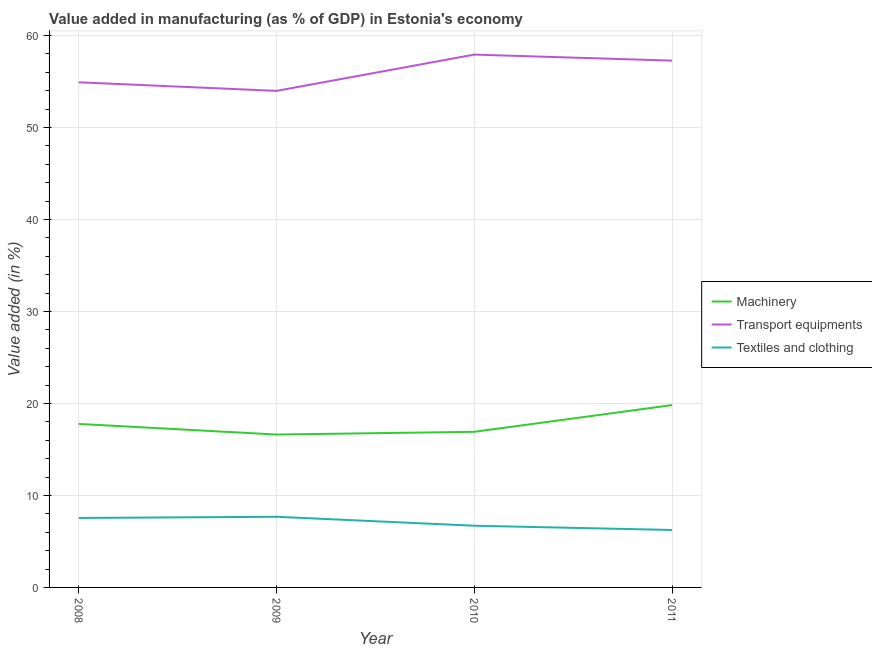How many different coloured lines are there?
Offer a terse response. 3. Is the number of lines equal to the number of legend labels?
Provide a succinct answer. Yes. What is the value added in manufacturing textile and clothing in 2009?
Keep it short and to the point. 7.68. Across all years, what is the maximum value added in manufacturing textile and clothing?
Ensure brevity in your answer.  7.68. Across all years, what is the minimum value added in manufacturing machinery?
Your answer should be compact. 16.62. In which year was the value added in manufacturing machinery minimum?
Offer a very short reply. 2009. What is the total value added in manufacturing machinery in the graph?
Your response must be concise. 71.12. What is the difference between the value added in manufacturing machinery in 2008 and that in 2011?
Provide a succinct answer. -2.05. What is the difference between the value added in manufacturing machinery in 2011 and the value added in manufacturing textile and clothing in 2009?
Your answer should be compact. 12.14. What is the average value added in manufacturing machinery per year?
Offer a terse response. 17.78. In the year 2011, what is the difference between the value added in manufacturing transport equipments and value added in manufacturing textile and clothing?
Keep it short and to the point. 51.01. What is the ratio of the value added in manufacturing textile and clothing in 2009 to that in 2010?
Provide a succinct answer. 1.15. Is the value added in manufacturing textile and clothing in 2008 less than that in 2011?
Give a very brief answer. No. What is the difference between the highest and the second highest value added in manufacturing textile and clothing?
Your answer should be very brief. 0.13. What is the difference between the highest and the lowest value added in manufacturing transport equipments?
Offer a terse response. 3.94. In how many years, is the value added in manufacturing machinery greater than the average value added in manufacturing machinery taken over all years?
Give a very brief answer. 1. Is it the case that in every year, the sum of the value added in manufacturing machinery and value added in manufacturing transport equipments is greater than the value added in manufacturing textile and clothing?
Offer a terse response. Yes. Does the value added in manufacturing textile and clothing monotonically increase over the years?
Your response must be concise. No. Is the value added in manufacturing machinery strictly greater than the value added in manufacturing transport equipments over the years?
Offer a very short reply. No. How many lines are there?
Your response must be concise. 3. Are the values on the major ticks of Y-axis written in scientific E-notation?
Offer a very short reply. No. Does the graph contain any zero values?
Your answer should be very brief. No. Does the graph contain grids?
Provide a succinct answer. Yes. What is the title of the graph?
Your response must be concise. Value added in manufacturing (as % of GDP) in Estonia's economy. Does "Renewable sources" appear as one of the legend labels in the graph?
Your answer should be very brief. No. What is the label or title of the Y-axis?
Ensure brevity in your answer.  Value added (in %). What is the Value added (in %) of Machinery in 2008?
Offer a very short reply. 17.77. What is the Value added (in %) in Transport equipments in 2008?
Your answer should be very brief. 54.9. What is the Value added (in %) in Textiles and clothing in 2008?
Provide a short and direct response. 7.55. What is the Value added (in %) of Machinery in 2009?
Provide a short and direct response. 16.62. What is the Value added (in %) in Transport equipments in 2009?
Make the answer very short. 53.97. What is the Value added (in %) of Textiles and clothing in 2009?
Provide a short and direct response. 7.68. What is the Value added (in %) in Machinery in 2010?
Make the answer very short. 16.92. What is the Value added (in %) of Transport equipments in 2010?
Provide a short and direct response. 57.92. What is the Value added (in %) of Textiles and clothing in 2010?
Give a very brief answer. 6.71. What is the Value added (in %) of Machinery in 2011?
Offer a very short reply. 19.82. What is the Value added (in %) of Transport equipments in 2011?
Offer a terse response. 57.26. What is the Value added (in %) of Textiles and clothing in 2011?
Your answer should be compact. 6.25. Across all years, what is the maximum Value added (in %) in Machinery?
Your answer should be very brief. 19.82. Across all years, what is the maximum Value added (in %) in Transport equipments?
Keep it short and to the point. 57.92. Across all years, what is the maximum Value added (in %) in Textiles and clothing?
Keep it short and to the point. 7.68. Across all years, what is the minimum Value added (in %) of Machinery?
Ensure brevity in your answer.  16.62. Across all years, what is the minimum Value added (in %) in Transport equipments?
Your response must be concise. 53.97. Across all years, what is the minimum Value added (in %) of Textiles and clothing?
Offer a very short reply. 6.25. What is the total Value added (in %) of Machinery in the graph?
Provide a short and direct response. 71.12. What is the total Value added (in %) of Transport equipments in the graph?
Provide a short and direct response. 224.05. What is the total Value added (in %) in Textiles and clothing in the graph?
Your answer should be very brief. 28.18. What is the difference between the Value added (in %) of Machinery in 2008 and that in 2009?
Keep it short and to the point. 1.15. What is the difference between the Value added (in %) of Transport equipments in 2008 and that in 2009?
Keep it short and to the point. 0.93. What is the difference between the Value added (in %) of Textiles and clothing in 2008 and that in 2009?
Provide a short and direct response. -0.13. What is the difference between the Value added (in %) in Machinery in 2008 and that in 2010?
Give a very brief answer. 0.86. What is the difference between the Value added (in %) in Transport equipments in 2008 and that in 2010?
Give a very brief answer. -3.01. What is the difference between the Value added (in %) of Textiles and clothing in 2008 and that in 2010?
Give a very brief answer. 0.84. What is the difference between the Value added (in %) in Machinery in 2008 and that in 2011?
Provide a succinct answer. -2.05. What is the difference between the Value added (in %) of Transport equipments in 2008 and that in 2011?
Make the answer very short. -2.36. What is the difference between the Value added (in %) in Textiles and clothing in 2008 and that in 2011?
Make the answer very short. 1.3. What is the difference between the Value added (in %) of Machinery in 2009 and that in 2010?
Offer a very short reply. -0.3. What is the difference between the Value added (in %) in Transport equipments in 2009 and that in 2010?
Offer a terse response. -3.94. What is the difference between the Value added (in %) in Textiles and clothing in 2009 and that in 2010?
Offer a terse response. 0.97. What is the difference between the Value added (in %) in Machinery in 2009 and that in 2011?
Offer a very short reply. -3.2. What is the difference between the Value added (in %) of Transport equipments in 2009 and that in 2011?
Give a very brief answer. -3.29. What is the difference between the Value added (in %) of Textiles and clothing in 2009 and that in 2011?
Provide a succinct answer. 1.43. What is the difference between the Value added (in %) of Machinery in 2010 and that in 2011?
Offer a terse response. -2.9. What is the difference between the Value added (in %) of Transport equipments in 2010 and that in 2011?
Offer a very short reply. 0.66. What is the difference between the Value added (in %) in Textiles and clothing in 2010 and that in 2011?
Ensure brevity in your answer.  0.46. What is the difference between the Value added (in %) in Machinery in 2008 and the Value added (in %) in Transport equipments in 2009?
Offer a terse response. -36.2. What is the difference between the Value added (in %) of Machinery in 2008 and the Value added (in %) of Textiles and clothing in 2009?
Keep it short and to the point. 10.09. What is the difference between the Value added (in %) in Transport equipments in 2008 and the Value added (in %) in Textiles and clothing in 2009?
Your response must be concise. 47.22. What is the difference between the Value added (in %) of Machinery in 2008 and the Value added (in %) of Transport equipments in 2010?
Make the answer very short. -40.14. What is the difference between the Value added (in %) in Machinery in 2008 and the Value added (in %) in Textiles and clothing in 2010?
Offer a very short reply. 11.07. What is the difference between the Value added (in %) of Transport equipments in 2008 and the Value added (in %) of Textiles and clothing in 2010?
Provide a short and direct response. 48.2. What is the difference between the Value added (in %) of Machinery in 2008 and the Value added (in %) of Transport equipments in 2011?
Your response must be concise. -39.49. What is the difference between the Value added (in %) of Machinery in 2008 and the Value added (in %) of Textiles and clothing in 2011?
Provide a succinct answer. 11.53. What is the difference between the Value added (in %) of Transport equipments in 2008 and the Value added (in %) of Textiles and clothing in 2011?
Offer a very short reply. 48.66. What is the difference between the Value added (in %) of Machinery in 2009 and the Value added (in %) of Transport equipments in 2010?
Your answer should be compact. -41.3. What is the difference between the Value added (in %) of Machinery in 2009 and the Value added (in %) of Textiles and clothing in 2010?
Provide a succinct answer. 9.91. What is the difference between the Value added (in %) in Transport equipments in 2009 and the Value added (in %) in Textiles and clothing in 2010?
Give a very brief answer. 47.27. What is the difference between the Value added (in %) in Machinery in 2009 and the Value added (in %) in Transport equipments in 2011?
Your answer should be very brief. -40.64. What is the difference between the Value added (in %) of Machinery in 2009 and the Value added (in %) of Textiles and clothing in 2011?
Make the answer very short. 10.37. What is the difference between the Value added (in %) of Transport equipments in 2009 and the Value added (in %) of Textiles and clothing in 2011?
Your response must be concise. 47.73. What is the difference between the Value added (in %) of Machinery in 2010 and the Value added (in %) of Transport equipments in 2011?
Your answer should be compact. -40.34. What is the difference between the Value added (in %) in Machinery in 2010 and the Value added (in %) in Textiles and clothing in 2011?
Make the answer very short. 10.67. What is the difference between the Value added (in %) of Transport equipments in 2010 and the Value added (in %) of Textiles and clothing in 2011?
Give a very brief answer. 51.67. What is the average Value added (in %) of Machinery per year?
Offer a very short reply. 17.78. What is the average Value added (in %) in Transport equipments per year?
Offer a very short reply. 56.01. What is the average Value added (in %) of Textiles and clothing per year?
Keep it short and to the point. 7.05. In the year 2008, what is the difference between the Value added (in %) in Machinery and Value added (in %) in Transport equipments?
Make the answer very short. -37.13. In the year 2008, what is the difference between the Value added (in %) of Machinery and Value added (in %) of Textiles and clothing?
Offer a very short reply. 10.22. In the year 2008, what is the difference between the Value added (in %) of Transport equipments and Value added (in %) of Textiles and clothing?
Provide a succinct answer. 47.35. In the year 2009, what is the difference between the Value added (in %) of Machinery and Value added (in %) of Transport equipments?
Offer a terse response. -37.36. In the year 2009, what is the difference between the Value added (in %) in Machinery and Value added (in %) in Textiles and clothing?
Offer a terse response. 8.94. In the year 2009, what is the difference between the Value added (in %) in Transport equipments and Value added (in %) in Textiles and clothing?
Offer a terse response. 46.29. In the year 2010, what is the difference between the Value added (in %) of Machinery and Value added (in %) of Transport equipments?
Your answer should be very brief. -41. In the year 2010, what is the difference between the Value added (in %) of Machinery and Value added (in %) of Textiles and clothing?
Provide a succinct answer. 10.21. In the year 2010, what is the difference between the Value added (in %) of Transport equipments and Value added (in %) of Textiles and clothing?
Offer a very short reply. 51.21. In the year 2011, what is the difference between the Value added (in %) in Machinery and Value added (in %) in Transport equipments?
Offer a very short reply. -37.44. In the year 2011, what is the difference between the Value added (in %) of Machinery and Value added (in %) of Textiles and clothing?
Your answer should be compact. 13.57. In the year 2011, what is the difference between the Value added (in %) in Transport equipments and Value added (in %) in Textiles and clothing?
Make the answer very short. 51.01. What is the ratio of the Value added (in %) in Machinery in 2008 to that in 2009?
Ensure brevity in your answer.  1.07. What is the ratio of the Value added (in %) in Transport equipments in 2008 to that in 2009?
Offer a terse response. 1.02. What is the ratio of the Value added (in %) of Textiles and clothing in 2008 to that in 2009?
Make the answer very short. 0.98. What is the ratio of the Value added (in %) of Machinery in 2008 to that in 2010?
Offer a very short reply. 1.05. What is the ratio of the Value added (in %) in Transport equipments in 2008 to that in 2010?
Provide a succinct answer. 0.95. What is the ratio of the Value added (in %) in Textiles and clothing in 2008 to that in 2010?
Make the answer very short. 1.13. What is the ratio of the Value added (in %) in Machinery in 2008 to that in 2011?
Keep it short and to the point. 0.9. What is the ratio of the Value added (in %) of Transport equipments in 2008 to that in 2011?
Offer a terse response. 0.96. What is the ratio of the Value added (in %) of Textiles and clothing in 2008 to that in 2011?
Offer a terse response. 1.21. What is the ratio of the Value added (in %) in Machinery in 2009 to that in 2010?
Make the answer very short. 0.98. What is the ratio of the Value added (in %) in Transport equipments in 2009 to that in 2010?
Provide a short and direct response. 0.93. What is the ratio of the Value added (in %) of Textiles and clothing in 2009 to that in 2010?
Ensure brevity in your answer.  1.15. What is the ratio of the Value added (in %) of Machinery in 2009 to that in 2011?
Your response must be concise. 0.84. What is the ratio of the Value added (in %) of Transport equipments in 2009 to that in 2011?
Your response must be concise. 0.94. What is the ratio of the Value added (in %) of Textiles and clothing in 2009 to that in 2011?
Your answer should be compact. 1.23. What is the ratio of the Value added (in %) of Machinery in 2010 to that in 2011?
Provide a succinct answer. 0.85. What is the ratio of the Value added (in %) of Transport equipments in 2010 to that in 2011?
Offer a very short reply. 1.01. What is the ratio of the Value added (in %) of Textiles and clothing in 2010 to that in 2011?
Offer a very short reply. 1.07. What is the difference between the highest and the second highest Value added (in %) in Machinery?
Provide a short and direct response. 2.05. What is the difference between the highest and the second highest Value added (in %) in Transport equipments?
Make the answer very short. 0.66. What is the difference between the highest and the second highest Value added (in %) of Textiles and clothing?
Provide a succinct answer. 0.13. What is the difference between the highest and the lowest Value added (in %) of Machinery?
Your answer should be compact. 3.2. What is the difference between the highest and the lowest Value added (in %) of Transport equipments?
Your answer should be very brief. 3.94. What is the difference between the highest and the lowest Value added (in %) in Textiles and clothing?
Provide a succinct answer. 1.43. 